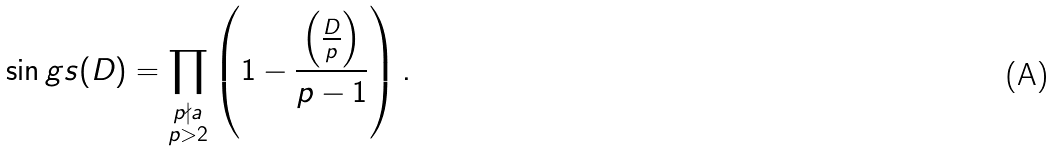<formula> <loc_0><loc_0><loc_500><loc_500>\sin g s ( D ) = \prod _ { \substack { p \nmid a \\ p > 2 } } \left ( 1 - \frac { \left ( \frac { D } { p } \right ) } { p - 1 } \right ) .</formula> 